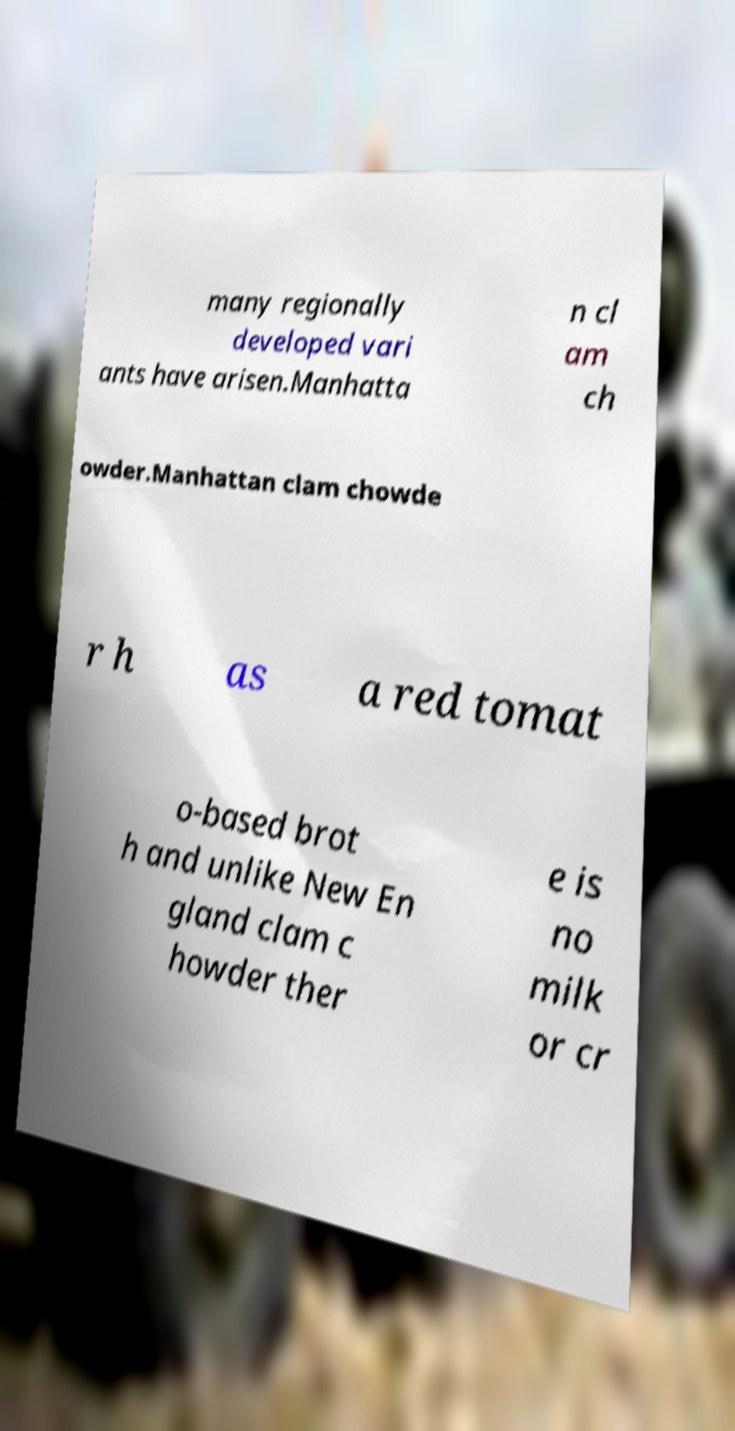Could you extract and type out the text from this image? many regionally developed vari ants have arisen.Manhatta n cl am ch owder.Manhattan clam chowde r h as a red tomat o-based brot h and unlike New En gland clam c howder ther e is no milk or cr 